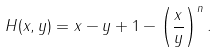Convert formula to latex. <formula><loc_0><loc_0><loc_500><loc_500>H ( x , y ) = x - y + 1 - \left ( \frac { x } { y } \right ) ^ { n } .</formula> 